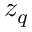Convert formula to latex. <formula><loc_0><loc_0><loc_500><loc_500>z _ { q }</formula> 